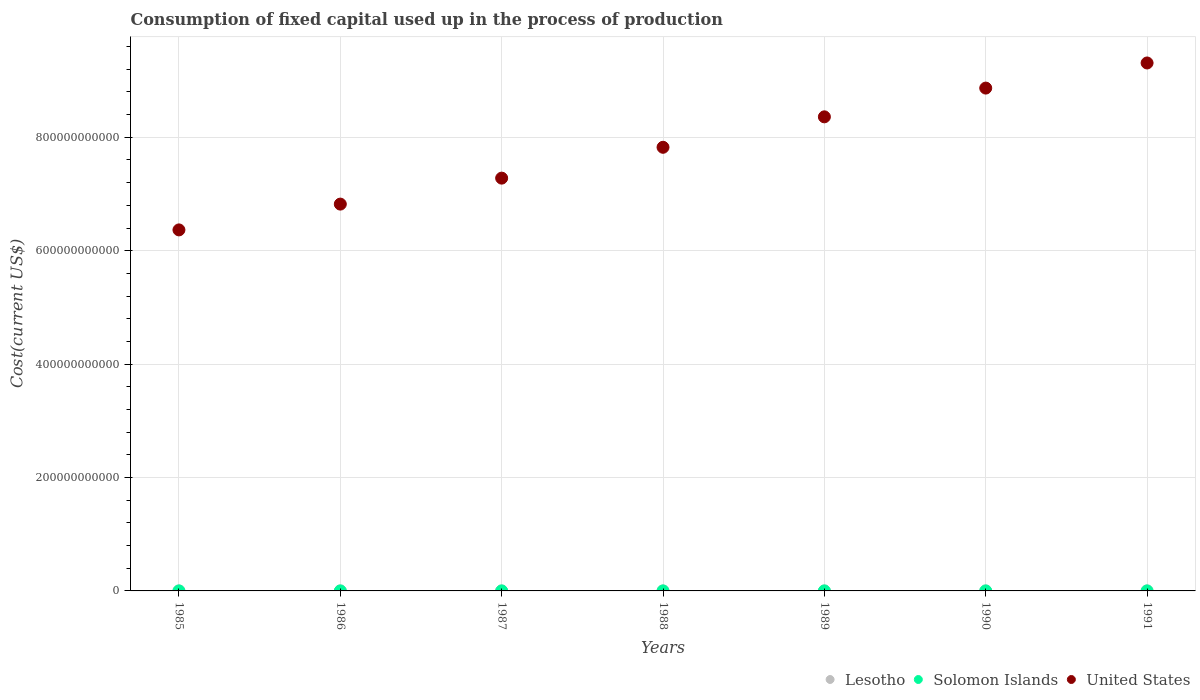How many different coloured dotlines are there?
Ensure brevity in your answer.  3. What is the amount consumed in the process of production in Lesotho in 1990?
Offer a terse response. 2.96e+07. Across all years, what is the maximum amount consumed in the process of production in United States?
Ensure brevity in your answer.  9.31e+11. Across all years, what is the minimum amount consumed in the process of production in Lesotho?
Make the answer very short. 1.82e+07. In which year was the amount consumed in the process of production in United States maximum?
Provide a short and direct response. 1991. In which year was the amount consumed in the process of production in Solomon Islands minimum?
Offer a terse response. 1985. What is the total amount consumed in the process of production in Lesotho in the graph?
Your answer should be compact. 1.80e+08. What is the difference between the amount consumed in the process of production in United States in 1988 and that in 1989?
Give a very brief answer. -5.37e+1. What is the difference between the amount consumed in the process of production in United States in 1989 and the amount consumed in the process of production in Lesotho in 1990?
Ensure brevity in your answer.  8.36e+11. What is the average amount consumed in the process of production in Solomon Islands per year?
Your answer should be compact. 2.07e+07. In the year 1989, what is the difference between the amount consumed in the process of production in Solomon Islands and amount consumed in the process of production in Lesotho?
Make the answer very short. 9.57e+04. In how many years, is the amount consumed in the process of production in Lesotho greater than 160000000000 US$?
Offer a terse response. 0. What is the ratio of the amount consumed in the process of production in United States in 1985 to that in 1987?
Provide a succinct answer. 0.87. Is the difference between the amount consumed in the process of production in Solomon Islands in 1988 and 1991 greater than the difference between the amount consumed in the process of production in Lesotho in 1988 and 1991?
Ensure brevity in your answer.  Yes. What is the difference between the highest and the second highest amount consumed in the process of production in Solomon Islands?
Your response must be concise. 1.83e+06. What is the difference between the highest and the lowest amount consumed in the process of production in Lesotho?
Offer a very short reply. 1.48e+07. In how many years, is the amount consumed in the process of production in Solomon Islands greater than the average amount consumed in the process of production in Solomon Islands taken over all years?
Make the answer very short. 4. Is it the case that in every year, the sum of the amount consumed in the process of production in Solomon Islands and amount consumed in the process of production in United States  is greater than the amount consumed in the process of production in Lesotho?
Give a very brief answer. Yes. Does the amount consumed in the process of production in Lesotho monotonically increase over the years?
Your response must be concise. No. How many years are there in the graph?
Provide a short and direct response. 7. What is the difference between two consecutive major ticks on the Y-axis?
Your answer should be very brief. 2.00e+11. Does the graph contain any zero values?
Your response must be concise. No. Does the graph contain grids?
Your response must be concise. Yes. What is the title of the graph?
Ensure brevity in your answer.  Consumption of fixed capital used up in the process of production. What is the label or title of the Y-axis?
Ensure brevity in your answer.  Cost(current US$). What is the Cost(current US$) in Lesotho in 1985?
Provide a short and direct response. 1.82e+07. What is the Cost(current US$) in Solomon Islands in 1985?
Your answer should be compact. 1.55e+07. What is the Cost(current US$) of United States in 1985?
Offer a terse response. 6.37e+11. What is the Cost(current US$) in Lesotho in 1986?
Give a very brief answer. 2.09e+07. What is the Cost(current US$) of Solomon Islands in 1986?
Your answer should be very brief. 1.59e+07. What is the Cost(current US$) of United States in 1986?
Offer a terse response. 6.82e+11. What is the Cost(current US$) of Lesotho in 1987?
Ensure brevity in your answer.  2.61e+07. What is the Cost(current US$) in Solomon Islands in 1987?
Keep it short and to the point. 1.81e+07. What is the Cost(current US$) of United States in 1987?
Provide a short and direct response. 7.28e+11. What is the Cost(current US$) of Lesotho in 1988?
Your answer should be very brief. 2.60e+07. What is the Cost(current US$) in Solomon Islands in 1988?
Ensure brevity in your answer.  2.42e+07. What is the Cost(current US$) of United States in 1988?
Your answer should be compact. 7.82e+11. What is the Cost(current US$) in Lesotho in 1989?
Your answer should be very brief. 2.59e+07. What is the Cost(current US$) of Solomon Islands in 1989?
Keep it short and to the point. 2.60e+07. What is the Cost(current US$) in United States in 1989?
Your response must be concise. 8.36e+11. What is the Cost(current US$) of Lesotho in 1990?
Provide a short and direct response. 2.96e+07. What is the Cost(current US$) in Solomon Islands in 1990?
Offer a terse response. 2.14e+07. What is the Cost(current US$) in United States in 1990?
Offer a very short reply. 8.87e+11. What is the Cost(current US$) in Lesotho in 1991?
Your answer should be compact. 3.30e+07. What is the Cost(current US$) in Solomon Islands in 1991?
Keep it short and to the point. 2.36e+07. What is the Cost(current US$) of United States in 1991?
Offer a very short reply. 9.31e+11. Across all years, what is the maximum Cost(current US$) in Lesotho?
Make the answer very short. 3.30e+07. Across all years, what is the maximum Cost(current US$) of Solomon Islands?
Your response must be concise. 2.60e+07. Across all years, what is the maximum Cost(current US$) of United States?
Give a very brief answer. 9.31e+11. Across all years, what is the minimum Cost(current US$) in Lesotho?
Keep it short and to the point. 1.82e+07. Across all years, what is the minimum Cost(current US$) in Solomon Islands?
Offer a terse response. 1.55e+07. Across all years, what is the minimum Cost(current US$) of United States?
Ensure brevity in your answer.  6.37e+11. What is the total Cost(current US$) in Lesotho in the graph?
Your answer should be compact. 1.80e+08. What is the total Cost(current US$) of Solomon Islands in the graph?
Offer a terse response. 1.45e+08. What is the total Cost(current US$) in United States in the graph?
Offer a terse response. 5.48e+12. What is the difference between the Cost(current US$) in Lesotho in 1985 and that in 1986?
Your response must be concise. -2.65e+06. What is the difference between the Cost(current US$) in Solomon Islands in 1985 and that in 1986?
Offer a terse response. -4.47e+05. What is the difference between the Cost(current US$) in United States in 1985 and that in 1986?
Your response must be concise. -4.55e+1. What is the difference between the Cost(current US$) in Lesotho in 1985 and that in 1987?
Offer a very short reply. -7.88e+06. What is the difference between the Cost(current US$) in Solomon Islands in 1985 and that in 1987?
Offer a very short reply. -2.65e+06. What is the difference between the Cost(current US$) of United States in 1985 and that in 1987?
Offer a very short reply. -9.13e+1. What is the difference between the Cost(current US$) in Lesotho in 1985 and that in 1988?
Your answer should be very brief. -7.74e+06. What is the difference between the Cost(current US$) of Solomon Islands in 1985 and that in 1988?
Give a very brief answer. -8.68e+06. What is the difference between the Cost(current US$) of United States in 1985 and that in 1988?
Offer a very short reply. -1.46e+11. What is the difference between the Cost(current US$) in Lesotho in 1985 and that in 1989?
Provide a succinct answer. -7.68e+06. What is the difference between the Cost(current US$) in Solomon Islands in 1985 and that in 1989?
Your response must be concise. -1.05e+07. What is the difference between the Cost(current US$) of United States in 1985 and that in 1989?
Your answer should be compact. -1.99e+11. What is the difference between the Cost(current US$) in Lesotho in 1985 and that in 1990?
Give a very brief answer. -1.14e+07. What is the difference between the Cost(current US$) in Solomon Islands in 1985 and that in 1990?
Offer a terse response. -5.94e+06. What is the difference between the Cost(current US$) in United States in 1985 and that in 1990?
Your answer should be very brief. -2.50e+11. What is the difference between the Cost(current US$) in Lesotho in 1985 and that in 1991?
Give a very brief answer. -1.48e+07. What is the difference between the Cost(current US$) in Solomon Islands in 1985 and that in 1991?
Provide a short and direct response. -8.07e+06. What is the difference between the Cost(current US$) in United States in 1985 and that in 1991?
Give a very brief answer. -2.94e+11. What is the difference between the Cost(current US$) of Lesotho in 1986 and that in 1987?
Ensure brevity in your answer.  -5.23e+06. What is the difference between the Cost(current US$) in Solomon Islands in 1986 and that in 1987?
Give a very brief answer. -2.20e+06. What is the difference between the Cost(current US$) in United States in 1986 and that in 1987?
Your answer should be very brief. -4.58e+1. What is the difference between the Cost(current US$) of Lesotho in 1986 and that in 1988?
Offer a terse response. -5.09e+06. What is the difference between the Cost(current US$) in Solomon Islands in 1986 and that in 1988?
Make the answer very short. -8.23e+06. What is the difference between the Cost(current US$) of United States in 1986 and that in 1988?
Offer a terse response. -1.00e+11. What is the difference between the Cost(current US$) of Lesotho in 1986 and that in 1989?
Your response must be concise. -5.03e+06. What is the difference between the Cost(current US$) in Solomon Islands in 1986 and that in 1989?
Your response must be concise. -1.01e+07. What is the difference between the Cost(current US$) of United States in 1986 and that in 1989?
Offer a very short reply. -1.54e+11. What is the difference between the Cost(current US$) of Lesotho in 1986 and that in 1990?
Offer a very short reply. -8.70e+06. What is the difference between the Cost(current US$) in Solomon Islands in 1986 and that in 1990?
Keep it short and to the point. -5.50e+06. What is the difference between the Cost(current US$) in United States in 1986 and that in 1990?
Your answer should be compact. -2.05e+11. What is the difference between the Cost(current US$) of Lesotho in 1986 and that in 1991?
Make the answer very short. -1.22e+07. What is the difference between the Cost(current US$) in Solomon Islands in 1986 and that in 1991?
Give a very brief answer. -7.62e+06. What is the difference between the Cost(current US$) of United States in 1986 and that in 1991?
Offer a terse response. -2.49e+11. What is the difference between the Cost(current US$) in Lesotho in 1987 and that in 1988?
Your answer should be very brief. 1.39e+05. What is the difference between the Cost(current US$) of Solomon Islands in 1987 and that in 1988?
Give a very brief answer. -6.04e+06. What is the difference between the Cost(current US$) of United States in 1987 and that in 1988?
Provide a short and direct response. -5.44e+1. What is the difference between the Cost(current US$) of Lesotho in 1987 and that in 1989?
Ensure brevity in your answer.  2.00e+05. What is the difference between the Cost(current US$) of Solomon Islands in 1987 and that in 1989?
Provide a short and direct response. -7.87e+06. What is the difference between the Cost(current US$) of United States in 1987 and that in 1989?
Your response must be concise. -1.08e+11. What is the difference between the Cost(current US$) in Lesotho in 1987 and that in 1990?
Keep it short and to the point. -3.47e+06. What is the difference between the Cost(current US$) in Solomon Islands in 1987 and that in 1990?
Offer a very short reply. -3.30e+06. What is the difference between the Cost(current US$) of United States in 1987 and that in 1990?
Give a very brief answer. -1.59e+11. What is the difference between the Cost(current US$) of Lesotho in 1987 and that in 1991?
Give a very brief answer. -6.93e+06. What is the difference between the Cost(current US$) of Solomon Islands in 1987 and that in 1991?
Provide a succinct answer. -5.42e+06. What is the difference between the Cost(current US$) in United States in 1987 and that in 1991?
Your response must be concise. -2.03e+11. What is the difference between the Cost(current US$) of Lesotho in 1988 and that in 1989?
Your answer should be very brief. 6.10e+04. What is the difference between the Cost(current US$) of Solomon Islands in 1988 and that in 1989?
Your response must be concise. -1.83e+06. What is the difference between the Cost(current US$) in United States in 1988 and that in 1989?
Your response must be concise. -5.37e+1. What is the difference between the Cost(current US$) of Lesotho in 1988 and that in 1990?
Your answer should be compact. -3.61e+06. What is the difference between the Cost(current US$) of Solomon Islands in 1988 and that in 1990?
Provide a succinct answer. 2.74e+06. What is the difference between the Cost(current US$) of United States in 1988 and that in 1990?
Offer a terse response. -1.04e+11. What is the difference between the Cost(current US$) of Lesotho in 1988 and that in 1991?
Provide a succinct answer. -7.07e+06. What is the difference between the Cost(current US$) in Solomon Islands in 1988 and that in 1991?
Make the answer very short. 6.13e+05. What is the difference between the Cost(current US$) of United States in 1988 and that in 1991?
Your answer should be compact. -1.49e+11. What is the difference between the Cost(current US$) in Lesotho in 1989 and that in 1990?
Make the answer very short. -3.67e+06. What is the difference between the Cost(current US$) in Solomon Islands in 1989 and that in 1990?
Ensure brevity in your answer.  4.57e+06. What is the difference between the Cost(current US$) in United States in 1989 and that in 1990?
Your answer should be compact. -5.07e+1. What is the difference between the Cost(current US$) of Lesotho in 1989 and that in 1991?
Provide a short and direct response. -7.13e+06. What is the difference between the Cost(current US$) in Solomon Islands in 1989 and that in 1991?
Make the answer very short. 2.44e+06. What is the difference between the Cost(current US$) of United States in 1989 and that in 1991?
Ensure brevity in your answer.  -9.50e+1. What is the difference between the Cost(current US$) of Lesotho in 1990 and that in 1991?
Offer a terse response. -3.46e+06. What is the difference between the Cost(current US$) of Solomon Islands in 1990 and that in 1991?
Your response must be concise. -2.13e+06. What is the difference between the Cost(current US$) in United States in 1990 and that in 1991?
Your answer should be very brief. -4.43e+1. What is the difference between the Cost(current US$) of Lesotho in 1985 and the Cost(current US$) of Solomon Islands in 1986?
Your answer should be very brief. 2.29e+06. What is the difference between the Cost(current US$) of Lesotho in 1985 and the Cost(current US$) of United States in 1986?
Your response must be concise. -6.82e+11. What is the difference between the Cost(current US$) in Solomon Islands in 1985 and the Cost(current US$) in United States in 1986?
Your answer should be compact. -6.82e+11. What is the difference between the Cost(current US$) in Lesotho in 1985 and the Cost(current US$) in Solomon Islands in 1987?
Your answer should be very brief. 8.87e+04. What is the difference between the Cost(current US$) of Lesotho in 1985 and the Cost(current US$) of United States in 1987?
Give a very brief answer. -7.28e+11. What is the difference between the Cost(current US$) in Solomon Islands in 1985 and the Cost(current US$) in United States in 1987?
Give a very brief answer. -7.28e+11. What is the difference between the Cost(current US$) of Lesotho in 1985 and the Cost(current US$) of Solomon Islands in 1988?
Offer a terse response. -5.95e+06. What is the difference between the Cost(current US$) of Lesotho in 1985 and the Cost(current US$) of United States in 1988?
Your answer should be very brief. -7.82e+11. What is the difference between the Cost(current US$) in Solomon Islands in 1985 and the Cost(current US$) in United States in 1988?
Provide a short and direct response. -7.82e+11. What is the difference between the Cost(current US$) in Lesotho in 1985 and the Cost(current US$) in Solomon Islands in 1989?
Provide a succinct answer. -7.78e+06. What is the difference between the Cost(current US$) of Lesotho in 1985 and the Cost(current US$) of United States in 1989?
Your answer should be compact. -8.36e+11. What is the difference between the Cost(current US$) of Solomon Islands in 1985 and the Cost(current US$) of United States in 1989?
Provide a succinct answer. -8.36e+11. What is the difference between the Cost(current US$) in Lesotho in 1985 and the Cost(current US$) in Solomon Islands in 1990?
Provide a short and direct response. -3.21e+06. What is the difference between the Cost(current US$) of Lesotho in 1985 and the Cost(current US$) of United States in 1990?
Offer a terse response. -8.87e+11. What is the difference between the Cost(current US$) in Solomon Islands in 1985 and the Cost(current US$) in United States in 1990?
Your answer should be compact. -8.87e+11. What is the difference between the Cost(current US$) in Lesotho in 1985 and the Cost(current US$) in Solomon Islands in 1991?
Your response must be concise. -5.34e+06. What is the difference between the Cost(current US$) of Lesotho in 1985 and the Cost(current US$) of United States in 1991?
Your response must be concise. -9.31e+11. What is the difference between the Cost(current US$) in Solomon Islands in 1985 and the Cost(current US$) in United States in 1991?
Make the answer very short. -9.31e+11. What is the difference between the Cost(current US$) in Lesotho in 1986 and the Cost(current US$) in Solomon Islands in 1987?
Ensure brevity in your answer.  2.74e+06. What is the difference between the Cost(current US$) in Lesotho in 1986 and the Cost(current US$) in United States in 1987?
Make the answer very short. -7.28e+11. What is the difference between the Cost(current US$) of Solomon Islands in 1986 and the Cost(current US$) of United States in 1987?
Your answer should be compact. -7.28e+11. What is the difference between the Cost(current US$) of Lesotho in 1986 and the Cost(current US$) of Solomon Islands in 1988?
Offer a very short reply. -3.30e+06. What is the difference between the Cost(current US$) in Lesotho in 1986 and the Cost(current US$) in United States in 1988?
Provide a short and direct response. -7.82e+11. What is the difference between the Cost(current US$) of Solomon Islands in 1986 and the Cost(current US$) of United States in 1988?
Your response must be concise. -7.82e+11. What is the difference between the Cost(current US$) of Lesotho in 1986 and the Cost(current US$) of Solomon Islands in 1989?
Keep it short and to the point. -5.13e+06. What is the difference between the Cost(current US$) in Lesotho in 1986 and the Cost(current US$) in United States in 1989?
Ensure brevity in your answer.  -8.36e+11. What is the difference between the Cost(current US$) of Solomon Islands in 1986 and the Cost(current US$) of United States in 1989?
Your answer should be very brief. -8.36e+11. What is the difference between the Cost(current US$) of Lesotho in 1986 and the Cost(current US$) of Solomon Islands in 1990?
Make the answer very short. -5.60e+05. What is the difference between the Cost(current US$) in Lesotho in 1986 and the Cost(current US$) in United States in 1990?
Keep it short and to the point. -8.87e+11. What is the difference between the Cost(current US$) of Solomon Islands in 1986 and the Cost(current US$) of United States in 1990?
Your response must be concise. -8.87e+11. What is the difference between the Cost(current US$) in Lesotho in 1986 and the Cost(current US$) in Solomon Islands in 1991?
Give a very brief answer. -2.69e+06. What is the difference between the Cost(current US$) in Lesotho in 1986 and the Cost(current US$) in United States in 1991?
Offer a very short reply. -9.31e+11. What is the difference between the Cost(current US$) in Solomon Islands in 1986 and the Cost(current US$) in United States in 1991?
Make the answer very short. -9.31e+11. What is the difference between the Cost(current US$) in Lesotho in 1987 and the Cost(current US$) in Solomon Islands in 1988?
Make the answer very short. 1.93e+06. What is the difference between the Cost(current US$) in Lesotho in 1987 and the Cost(current US$) in United States in 1988?
Your response must be concise. -7.82e+11. What is the difference between the Cost(current US$) in Solomon Islands in 1987 and the Cost(current US$) in United States in 1988?
Make the answer very short. -7.82e+11. What is the difference between the Cost(current US$) of Lesotho in 1987 and the Cost(current US$) of Solomon Islands in 1989?
Offer a terse response. 1.05e+05. What is the difference between the Cost(current US$) of Lesotho in 1987 and the Cost(current US$) of United States in 1989?
Your answer should be very brief. -8.36e+11. What is the difference between the Cost(current US$) in Solomon Islands in 1987 and the Cost(current US$) in United States in 1989?
Give a very brief answer. -8.36e+11. What is the difference between the Cost(current US$) in Lesotho in 1987 and the Cost(current US$) in Solomon Islands in 1990?
Make the answer very short. 4.67e+06. What is the difference between the Cost(current US$) of Lesotho in 1987 and the Cost(current US$) of United States in 1990?
Provide a short and direct response. -8.87e+11. What is the difference between the Cost(current US$) in Solomon Islands in 1987 and the Cost(current US$) in United States in 1990?
Keep it short and to the point. -8.87e+11. What is the difference between the Cost(current US$) in Lesotho in 1987 and the Cost(current US$) in Solomon Islands in 1991?
Your response must be concise. 2.55e+06. What is the difference between the Cost(current US$) of Lesotho in 1987 and the Cost(current US$) of United States in 1991?
Ensure brevity in your answer.  -9.31e+11. What is the difference between the Cost(current US$) of Solomon Islands in 1987 and the Cost(current US$) of United States in 1991?
Make the answer very short. -9.31e+11. What is the difference between the Cost(current US$) of Lesotho in 1988 and the Cost(current US$) of Solomon Islands in 1989?
Your response must be concise. -3.47e+04. What is the difference between the Cost(current US$) in Lesotho in 1988 and the Cost(current US$) in United States in 1989?
Give a very brief answer. -8.36e+11. What is the difference between the Cost(current US$) in Solomon Islands in 1988 and the Cost(current US$) in United States in 1989?
Ensure brevity in your answer.  -8.36e+11. What is the difference between the Cost(current US$) of Lesotho in 1988 and the Cost(current US$) of Solomon Islands in 1990?
Offer a terse response. 4.53e+06. What is the difference between the Cost(current US$) of Lesotho in 1988 and the Cost(current US$) of United States in 1990?
Your response must be concise. -8.87e+11. What is the difference between the Cost(current US$) of Solomon Islands in 1988 and the Cost(current US$) of United States in 1990?
Ensure brevity in your answer.  -8.87e+11. What is the difference between the Cost(current US$) of Lesotho in 1988 and the Cost(current US$) of Solomon Islands in 1991?
Ensure brevity in your answer.  2.41e+06. What is the difference between the Cost(current US$) of Lesotho in 1988 and the Cost(current US$) of United States in 1991?
Your answer should be compact. -9.31e+11. What is the difference between the Cost(current US$) of Solomon Islands in 1988 and the Cost(current US$) of United States in 1991?
Keep it short and to the point. -9.31e+11. What is the difference between the Cost(current US$) in Lesotho in 1989 and the Cost(current US$) in Solomon Islands in 1990?
Give a very brief answer. 4.47e+06. What is the difference between the Cost(current US$) in Lesotho in 1989 and the Cost(current US$) in United States in 1990?
Provide a short and direct response. -8.87e+11. What is the difference between the Cost(current US$) of Solomon Islands in 1989 and the Cost(current US$) of United States in 1990?
Offer a very short reply. -8.87e+11. What is the difference between the Cost(current US$) in Lesotho in 1989 and the Cost(current US$) in Solomon Islands in 1991?
Offer a very short reply. 2.35e+06. What is the difference between the Cost(current US$) of Lesotho in 1989 and the Cost(current US$) of United States in 1991?
Your answer should be compact. -9.31e+11. What is the difference between the Cost(current US$) in Solomon Islands in 1989 and the Cost(current US$) in United States in 1991?
Provide a short and direct response. -9.31e+11. What is the difference between the Cost(current US$) of Lesotho in 1990 and the Cost(current US$) of Solomon Islands in 1991?
Provide a succinct answer. 6.02e+06. What is the difference between the Cost(current US$) in Lesotho in 1990 and the Cost(current US$) in United States in 1991?
Offer a very short reply. -9.31e+11. What is the difference between the Cost(current US$) in Solomon Islands in 1990 and the Cost(current US$) in United States in 1991?
Keep it short and to the point. -9.31e+11. What is the average Cost(current US$) in Lesotho per year?
Make the answer very short. 2.57e+07. What is the average Cost(current US$) of Solomon Islands per year?
Provide a succinct answer. 2.07e+07. What is the average Cost(current US$) in United States per year?
Your response must be concise. 7.83e+11. In the year 1985, what is the difference between the Cost(current US$) of Lesotho and Cost(current US$) of Solomon Islands?
Keep it short and to the point. 2.73e+06. In the year 1985, what is the difference between the Cost(current US$) in Lesotho and Cost(current US$) in United States?
Offer a terse response. -6.37e+11. In the year 1985, what is the difference between the Cost(current US$) in Solomon Islands and Cost(current US$) in United States?
Offer a very short reply. -6.37e+11. In the year 1986, what is the difference between the Cost(current US$) of Lesotho and Cost(current US$) of Solomon Islands?
Your answer should be very brief. 4.94e+06. In the year 1986, what is the difference between the Cost(current US$) in Lesotho and Cost(current US$) in United States?
Give a very brief answer. -6.82e+11. In the year 1986, what is the difference between the Cost(current US$) in Solomon Islands and Cost(current US$) in United States?
Offer a terse response. -6.82e+11. In the year 1987, what is the difference between the Cost(current US$) in Lesotho and Cost(current US$) in Solomon Islands?
Provide a succinct answer. 7.97e+06. In the year 1987, what is the difference between the Cost(current US$) in Lesotho and Cost(current US$) in United States?
Your answer should be compact. -7.28e+11. In the year 1987, what is the difference between the Cost(current US$) of Solomon Islands and Cost(current US$) of United States?
Keep it short and to the point. -7.28e+11. In the year 1988, what is the difference between the Cost(current US$) in Lesotho and Cost(current US$) in Solomon Islands?
Offer a terse response. 1.79e+06. In the year 1988, what is the difference between the Cost(current US$) in Lesotho and Cost(current US$) in United States?
Your answer should be very brief. -7.82e+11. In the year 1988, what is the difference between the Cost(current US$) of Solomon Islands and Cost(current US$) of United States?
Your response must be concise. -7.82e+11. In the year 1989, what is the difference between the Cost(current US$) in Lesotho and Cost(current US$) in Solomon Islands?
Your answer should be very brief. -9.57e+04. In the year 1989, what is the difference between the Cost(current US$) of Lesotho and Cost(current US$) of United States?
Your response must be concise. -8.36e+11. In the year 1989, what is the difference between the Cost(current US$) of Solomon Islands and Cost(current US$) of United States?
Your answer should be compact. -8.36e+11. In the year 1990, what is the difference between the Cost(current US$) of Lesotho and Cost(current US$) of Solomon Islands?
Make the answer very short. 8.14e+06. In the year 1990, what is the difference between the Cost(current US$) in Lesotho and Cost(current US$) in United States?
Ensure brevity in your answer.  -8.87e+11. In the year 1990, what is the difference between the Cost(current US$) of Solomon Islands and Cost(current US$) of United States?
Provide a succinct answer. -8.87e+11. In the year 1991, what is the difference between the Cost(current US$) in Lesotho and Cost(current US$) in Solomon Islands?
Your answer should be very brief. 9.47e+06. In the year 1991, what is the difference between the Cost(current US$) of Lesotho and Cost(current US$) of United States?
Your answer should be very brief. -9.31e+11. In the year 1991, what is the difference between the Cost(current US$) of Solomon Islands and Cost(current US$) of United States?
Offer a very short reply. -9.31e+11. What is the ratio of the Cost(current US$) of Lesotho in 1985 to that in 1986?
Your answer should be compact. 0.87. What is the ratio of the Cost(current US$) of Solomon Islands in 1985 to that in 1986?
Make the answer very short. 0.97. What is the ratio of the Cost(current US$) in Lesotho in 1985 to that in 1987?
Offer a terse response. 0.7. What is the ratio of the Cost(current US$) of Solomon Islands in 1985 to that in 1987?
Give a very brief answer. 0.85. What is the ratio of the Cost(current US$) in United States in 1985 to that in 1987?
Your answer should be very brief. 0.87. What is the ratio of the Cost(current US$) in Lesotho in 1985 to that in 1988?
Your answer should be very brief. 0.7. What is the ratio of the Cost(current US$) in Solomon Islands in 1985 to that in 1988?
Your response must be concise. 0.64. What is the ratio of the Cost(current US$) of United States in 1985 to that in 1988?
Your response must be concise. 0.81. What is the ratio of the Cost(current US$) in Lesotho in 1985 to that in 1989?
Your answer should be compact. 0.7. What is the ratio of the Cost(current US$) in Solomon Islands in 1985 to that in 1989?
Offer a terse response. 0.6. What is the ratio of the Cost(current US$) in United States in 1985 to that in 1989?
Provide a succinct answer. 0.76. What is the ratio of the Cost(current US$) of Lesotho in 1985 to that in 1990?
Your response must be concise. 0.62. What is the ratio of the Cost(current US$) in Solomon Islands in 1985 to that in 1990?
Ensure brevity in your answer.  0.72. What is the ratio of the Cost(current US$) in United States in 1985 to that in 1990?
Make the answer very short. 0.72. What is the ratio of the Cost(current US$) in Lesotho in 1985 to that in 1991?
Provide a succinct answer. 0.55. What is the ratio of the Cost(current US$) in Solomon Islands in 1985 to that in 1991?
Provide a short and direct response. 0.66. What is the ratio of the Cost(current US$) of United States in 1985 to that in 1991?
Keep it short and to the point. 0.68. What is the ratio of the Cost(current US$) in Lesotho in 1986 to that in 1987?
Keep it short and to the point. 0.8. What is the ratio of the Cost(current US$) in Solomon Islands in 1986 to that in 1987?
Give a very brief answer. 0.88. What is the ratio of the Cost(current US$) of United States in 1986 to that in 1987?
Provide a short and direct response. 0.94. What is the ratio of the Cost(current US$) of Lesotho in 1986 to that in 1988?
Provide a short and direct response. 0.8. What is the ratio of the Cost(current US$) of Solomon Islands in 1986 to that in 1988?
Your answer should be compact. 0.66. What is the ratio of the Cost(current US$) of United States in 1986 to that in 1988?
Make the answer very short. 0.87. What is the ratio of the Cost(current US$) of Lesotho in 1986 to that in 1989?
Provide a short and direct response. 0.81. What is the ratio of the Cost(current US$) of Solomon Islands in 1986 to that in 1989?
Your response must be concise. 0.61. What is the ratio of the Cost(current US$) of United States in 1986 to that in 1989?
Offer a terse response. 0.82. What is the ratio of the Cost(current US$) of Lesotho in 1986 to that in 1990?
Give a very brief answer. 0.71. What is the ratio of the Cost(current US$) of Solomon Islands in 1986 to that in 1990?
Keep it short and to the point. 0.74. What is the ratio of the Cost(current US$) of United States in 1986 to that in 1990?
Give a very brief answer. 0.77. What is the ratio of the Cost(current US$) in Lesotho in 1986 to that in 1991?
Offer a terse response. 0.63. What is the ratio of the Cost(current US$) in Solomon Islands in 1986 to that in 1991?
Your answer should be very brief. 0.68. What is the ratio of the Cost(current US$) of United States in 1986 to that in 1991?
Provide a short and direct response. 0.73. What is the ratio of the Cost(current US$) of Lesotho in 1987 to that in 1988?
Provide a short and direct response. 1.01. What is the ratio of the Cost(current US$) of Solomon Islands in 1987 to that in 1988?
Offer a very short reply. 0.75. What is the ratio of the Cost(current US$) of United States in 1987 to that in 1988?
Your answer should be very brief. 0.93. What is the ratio of the Cost(current US$) of Lesotho in 1987 to that in 1989?
Ensure brevity in your answer.  1.01. What is the ratio of the Cost(current US$) of Solomon Islands in 1987 to that in 1989?
Offer a terse response. 0.7. What is the ratio of the Cost(current US$) of United States in 1987 to that in 1989?
Your answer should be very brief. 0.87. What is the ratio of the Cost(current US$) in Lesotho in 1987 to that in 1990?
Provide a succinct answer. 0.88. What is the ratio of the Cost(current US$) of Solomon Islands in 1987 to that in 1990?
Offer a terse response. 0.85. What is the ratio of the Cost(current US$) of United States in 1987 to that in 1990?
Your answer should be very brief. 0.82. What is the ratio of the Cost(current US$) of Lesotho in 1987 to that in 1991?
Provide a succinct answer. 0.79. What is the ratio of the Cost(current US$) of Solomon Islands in 1987 to that in 1991?
Offer a terse response. 0.77. What is the ratio of the Cost(current US$) of United States in 1987 to that in 1991?
Offer a terse response. 0.78. What is the ratio of the Cost(current US$) of Lesotho in 1988 to that in 1989?
Your answer should be very brief. 1. What is the ratio of the Cost(current US$) of Solomon Islands in 1988 to that in 1989?
Offer a very short reply. 0.93. What is the ratio of the Cost(current US$) in United States in 1988 to that in 1989?
Offer a terse response. 0.94. What is the ratio of the Cost(current US$) in Lesotho in 1988 to that in 1990?
Keep it short and to the point. 0.88. What is the ratio of the Cost(current US$) of Solomon Islands in 1988 to that in 1990?
Your answer should be very brief. 1.13. What is the ratio of the Cost(current US$) of United States in 1988 to that in 1990?
Your answer should be very brief. 0.88. What is the ratio of the Cost(current US$) in Lesotho in 1988 to that in 1991?
Offer a very short reply. 0.79. What is the ratio of the Cost(current US$) in United States in 1988 to that in 1991?
Offer a terse response. 0.84. What is the ratio of the Cost(current US$) in Lesotho in 1989 to that in 1990?
Your answer should be very brief. 0.88. What is the ratio of the Cost(current US$) of Solomon Islands in 1989 to that in 1990?
Ensure brevity in your answer.  1.21. What is the ratio of the Cost(current US$) of United States in 1989 to that in 1990?
Keep it short and to the point. 0.94. What is the ratio of the Cost(current US$) of Lesotho in 1989 to that in 1991?
Your answer should be compact. 0.78. What is the ratio of the Cost(current US$) of Solomon Islands in 1989 to that in 1991?
Keep it short and to the point. 1.1. What is the ratio of the Cost(current US$) in United States in 1989 to that in 1991?
Your answer should be compact. 0.9. What is the ratio of the Cost(current US$) in Lesotho in 1990 to that in 1991?
Keep it short and to the point. 0.9. What is the ratio of the Cost(current US$) of Solomon Islands in 1990 to that in 1991?
Your response must be concise. 0.91. What is the difference between the highest and the second highest Cost(current US$) of Lesotho?
Keep it short and to the point. 3.46e+06. What is the difference between the highest and the second highest Cost(current US$) in Solomon Islands?
Your response must be concise. 1.83e+06. What is the difference between the highest and the second highest Cost(current US$) of United States?
Your answer should be compact. 4.43e+1. What is the difference between the highest and the lowest Cost(current US$) in Lesotho?
Offer a very short reply. 1.48e+07. What is the difference between the highest and the lowest Cost(current US$) of Solomon Islands?
Keep it short and to the point. 1.05e+07. What is the difference between the highest and the lowest Cost(current US$) in United States?
Offer a very short reply. 2.94e+11. 